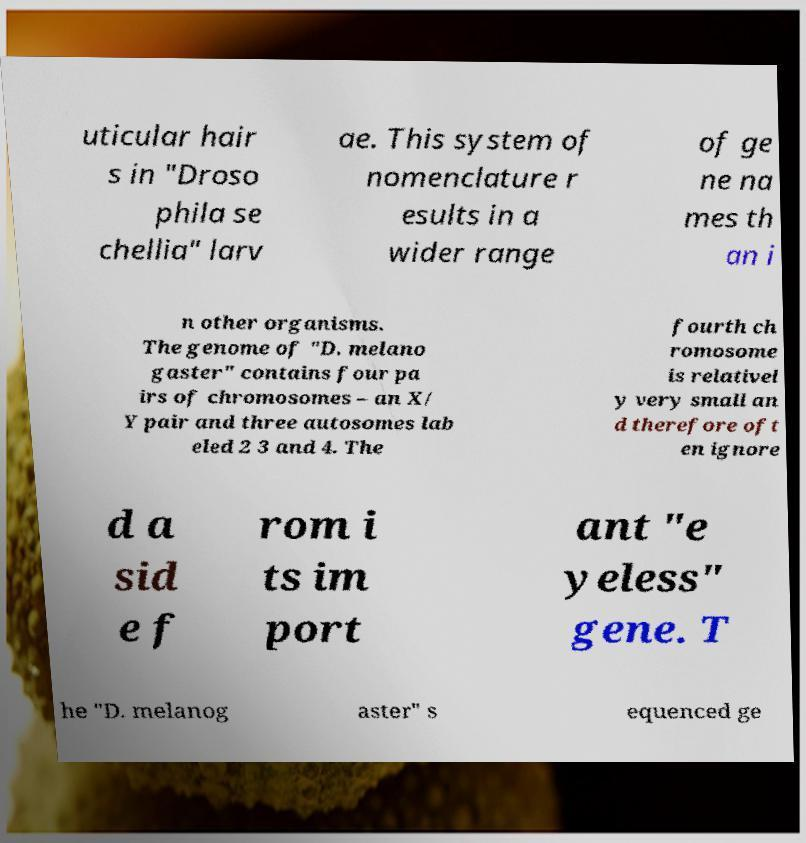Can you read and provide the text displayed in the image?This photo seems to have some interesting text. Can you extract and type it out for me? uticular hair s in "Droso phila se chellia" larv ae. This system of nomenclature r esults in a wider range of ge ne na mes th an i n other organisms. The genome of "D. melano gaster" contains four pa irs of chromosomes – an X/ Y pair and three autosomes lab eled 2 3 and 4. The fourth ch romosome is relativel y very small an d therefore oft en ignore d a sid e f rom i ts im port ant "e yeless" gene. T he "D. melanog aster" s equenced ge 